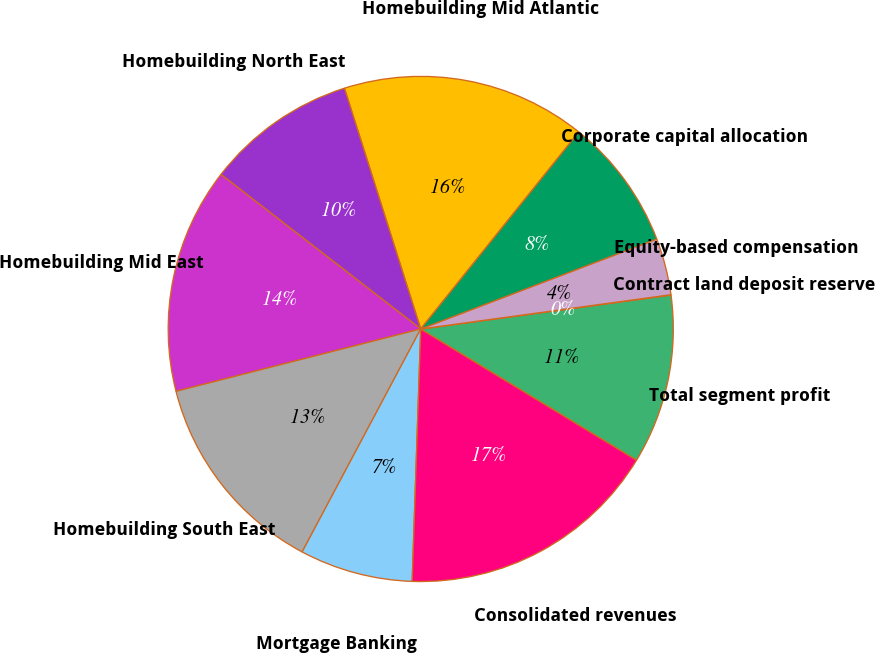Convert chart. <chart><loc_0><loc_0><loc_500><loc_500><pie_chart><fcel>Homebuilding Mid Atlantic<fcel>Homebuilding North East<fcel>Homebuilding Mid East<fcel>Homebuilding South East<fcel>Mortgage Banking<fcel>Consolidated revenues<fcel>Total segment profit<fcel>Contract land deposit reserve<fcel>Equity-based compensation<fcel>Corporate capital allocation<nl><fcel>15.65%<fcel>9.64%<fcel>14.45%<fcel>13.25%<fcel>7.24%<fcel>16.85%<fcel>10.84%<fcel>0.02%<fcel>3.63%<fcel>8.44%<nl></chart> 